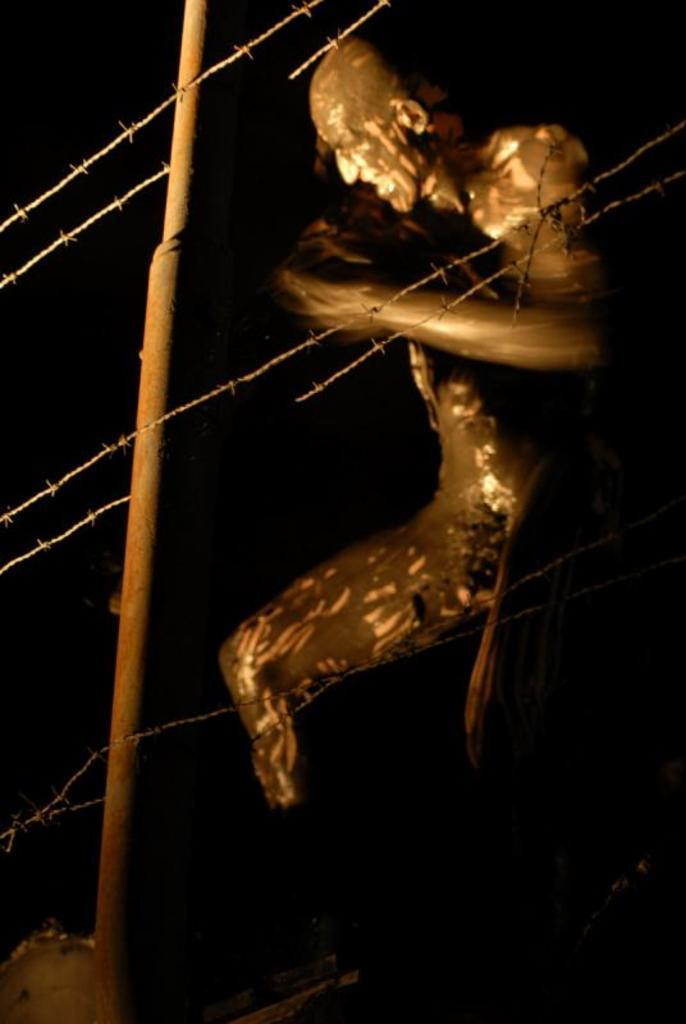What is the main subject of the image? There is a person in the image. What can be observed about the person's appearance? The person has mud on them. What is in front of the person? There is a fence and a pole in front of the person. What is the color of the background in the image? The background of the image is black. What type of blood is visible on the person's clothes in the image? There is no blood visible on the person's clothes in the image; they have mud on them. What story is being told by the person in the image? The image does not depict a story being told; it simply shows a person with mud on them and a fence and pole in front of them. 